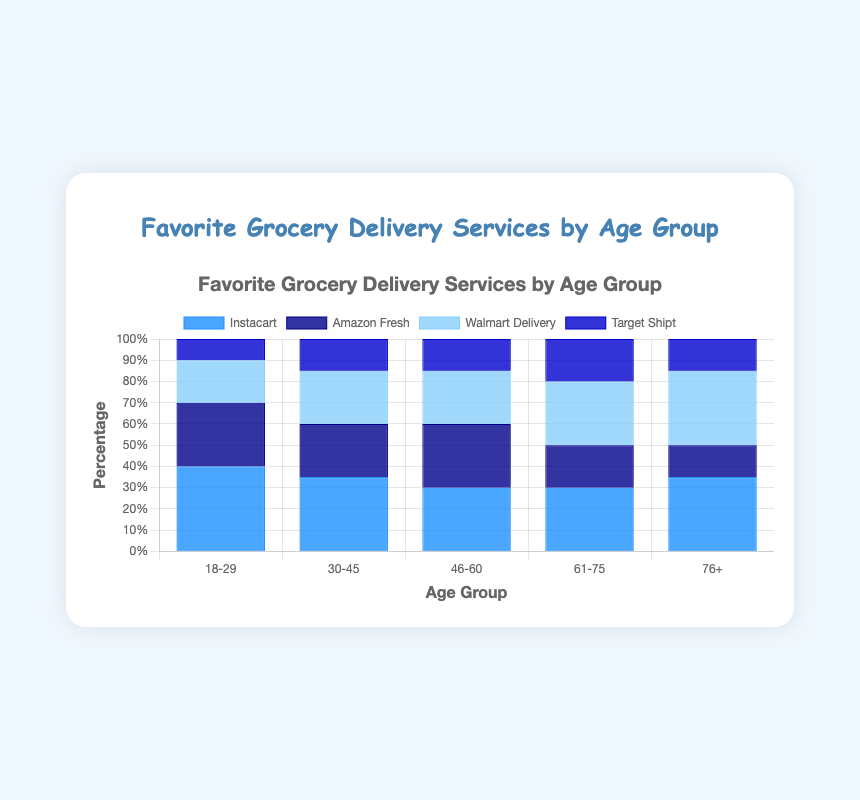Which age group prefers Walmart Delivery the most? Walmart Delivery has the highest bar for the 76+ age group, indicating that they have the highest percentage preference compared to other age groups.
Answer: 76+ How does the preference for Instacart change from the 18-29 age group to the 61-75 age group? Compare the Instacart bars for both age groups. The preference decreases from 40% in the 18-29 age group to 30% in the 61-75 age group.
Answer: It decreases Which grocery delivery service is least preferred by people aged 18-29? The shortest bar for the 18-29 age group is Target Shipt, indicating it is the least preferred service.
Answer: Target Shipt What is the overall trend for Amazon Fresh across all age groups? Observing the bars for Amazon Fresh across all age groups, it starts high with the 18-29 group at 30%, decreases to 25% in the 30-45 group, remains stable for 46-60, then decreases further to 20% in the 61-75 group and 15% in the 76+ group.
Answer: Decreasing Which delivery service is equally preferred by people aged 46-60? For the 46-60 age group, Instacart and Amazon Fresh both have bars of equal height at 30%, indicating equal preference.
Answer: Instacart and Amazon Fresh What is the difference in preference percentage for Walmart Delivery between the 61-75 and 76+ age groups? The bar height for Walmart Delivery in the 61-75 group is 30%, and in the 76+ group is also 35%. The difference is 35% - 30% = 5%.
Answer: 5% Across all age groups, which grocery delivery service has the most consistent level of preference? Observing all four bars for each service across age groups, Instacart has a fairly consistent preference level, ranging from 30% to 40%. Other services show more variation.
Answer: Instacart Which age groups show equal preference percentages for Target Shipt? The bars for Target Shipt at 15% are equal for the 30-45 age group and the 46-60 age group.
Answer: 30-45 and 46-60 How many age groups prefer Amazon Fresh more than Walmart Delivery? Comparing Amazon Fresh and Walmart Delivery bars for each age group, the 18-29 and 46-60 groups have higher preferences for Amazon Fresh.
Answer: 2 What is the highest preference percentage across all services and age groups? The tallest bar across the chart is for Instacart in the 18-29 age group at 40%.
Answer: 40% 